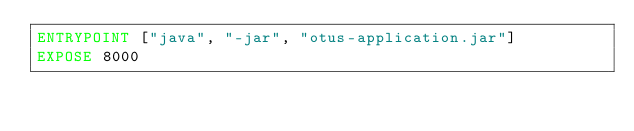Convert code to text. <code><loc_0><loc_0><loc_500><loc_500><_Dockerfile_>ENTRYPOINT ["java", "-jar", "otus-application.jar"]
EXPOSE 8000
</code> 